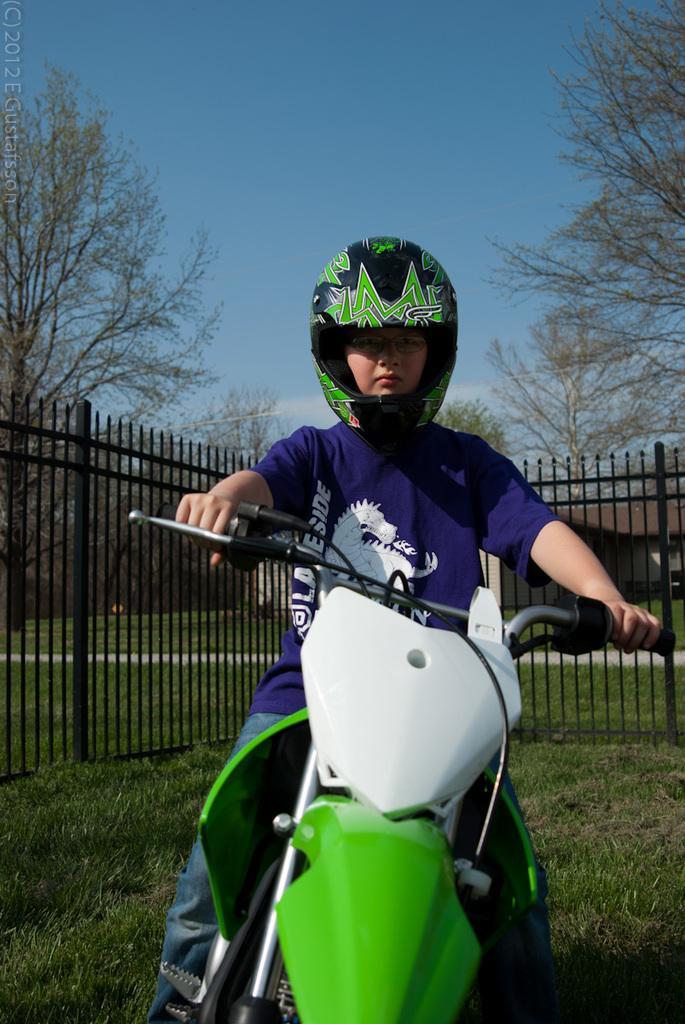Can you describe this image briefly? In this picture we can see a person wearing a helmet and a spectacle. This person is sitting on a vehicle. Some grass is visible on the ground. There is some fencing visible from left to right. We can see a few trees in the background. Sky is blue in color. 